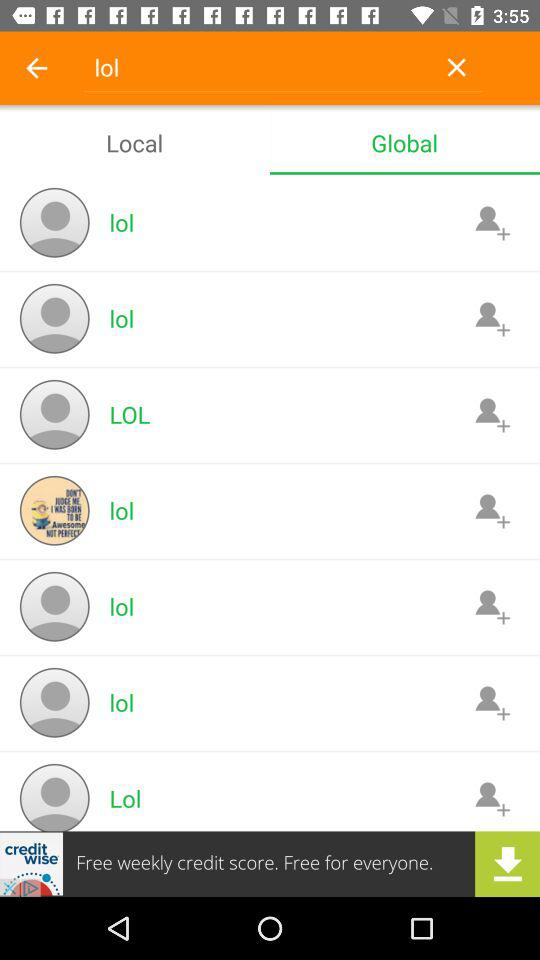Which tab is currently selected? The currently selected tab is "Global". 